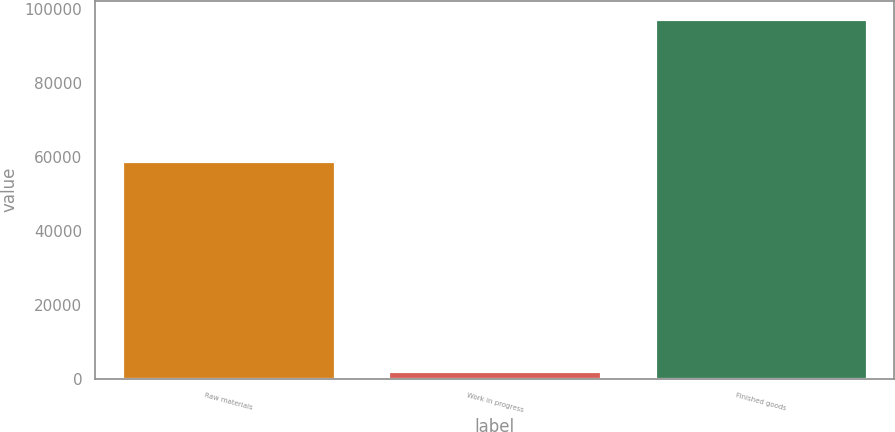<chart> <loc_0><loc_0><loc_500><loc_500><bar_chart><fcel>Raw materials<fcel>Work in progress<fcel>Finished goods<nl><fcel>58768<fcel>2165<fcel>97318<nl></chart> 